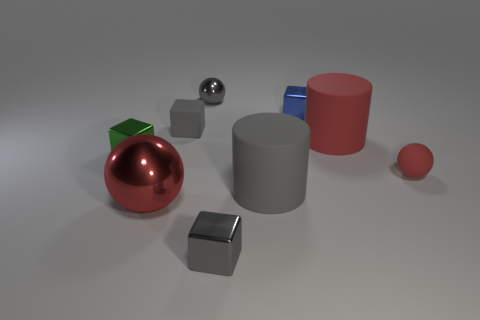The red object that is made of the same material as the big red cylinder is what shape?
Keep it short and to the point. Sphere. There is a small rubber object on the right side of the tiny gray metallic sphere; is it the same shape as the tiny green object?
Provide a succinct answer. No. What number of objects are small purple cubes or red matte spheres?
Provide a succinct answer. 1. There is a sphere that is both behind the big gray rubber cylinder and left of the blue object; what is its material?
Provide a short and direct response. Metal. Does the green metal thing have the same size as the blue metal cube?
Your response must be concise. Yes. How big is the metallic ball that is in front of the red sphere that is on the right side of the small blue block?
Give a very brief answer. Large. How many matte things are behind the green block and on the left side of the big red rubber object?
Your answer should be very brief. 1. Is there a gray matte thing on the right side of the cylinder that is behind the matte cylinder left of the blue thing?
Offer a terse response. No. What is the shape of the red object that is the same size as the blue cube?
Make the answer very short. Sphere. Is there another sphere of the same color as the large ball?
Your response must be concise. Yes. 